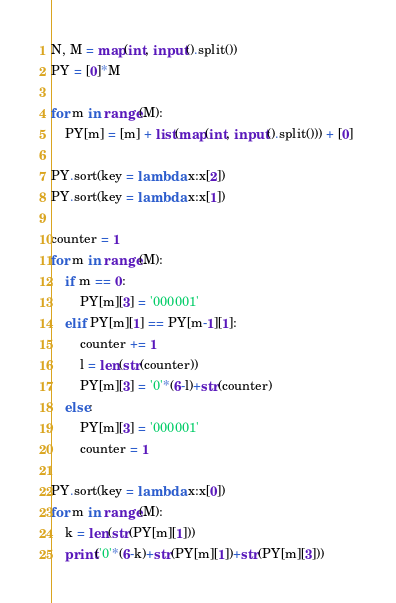<code> <loc_0><loc_0><loc_500><loc_500><_Python_>N, M = map(int, input().split())
PY = [0]*M

for m in range(M):
    PY[m] = [m] + list(map(int, input().split())) + [0] 
    
PY.sort(key = lambda x:x[2])
PY.sort(key = lambda x:x[1])

counter = 1 
for m in range(M):
    if m == 0:
        PY[m][3] = '000001'
    elif PY[m][1] == PY[m-1][1]:
        counter += 1
        l = len(str(counter))
        PY[m][3] = '0'*(6-l)+str(counter)
    else:
        PY[m][3] = '000001'
        counter = 1
        
PY.sort(key = lambda x:x[0])
for m in range(M):
    k = len(str(PY[m][1]))
    print('0'*(6-k)+str(PY[m][1])+str(PY[m][3]))</code> 